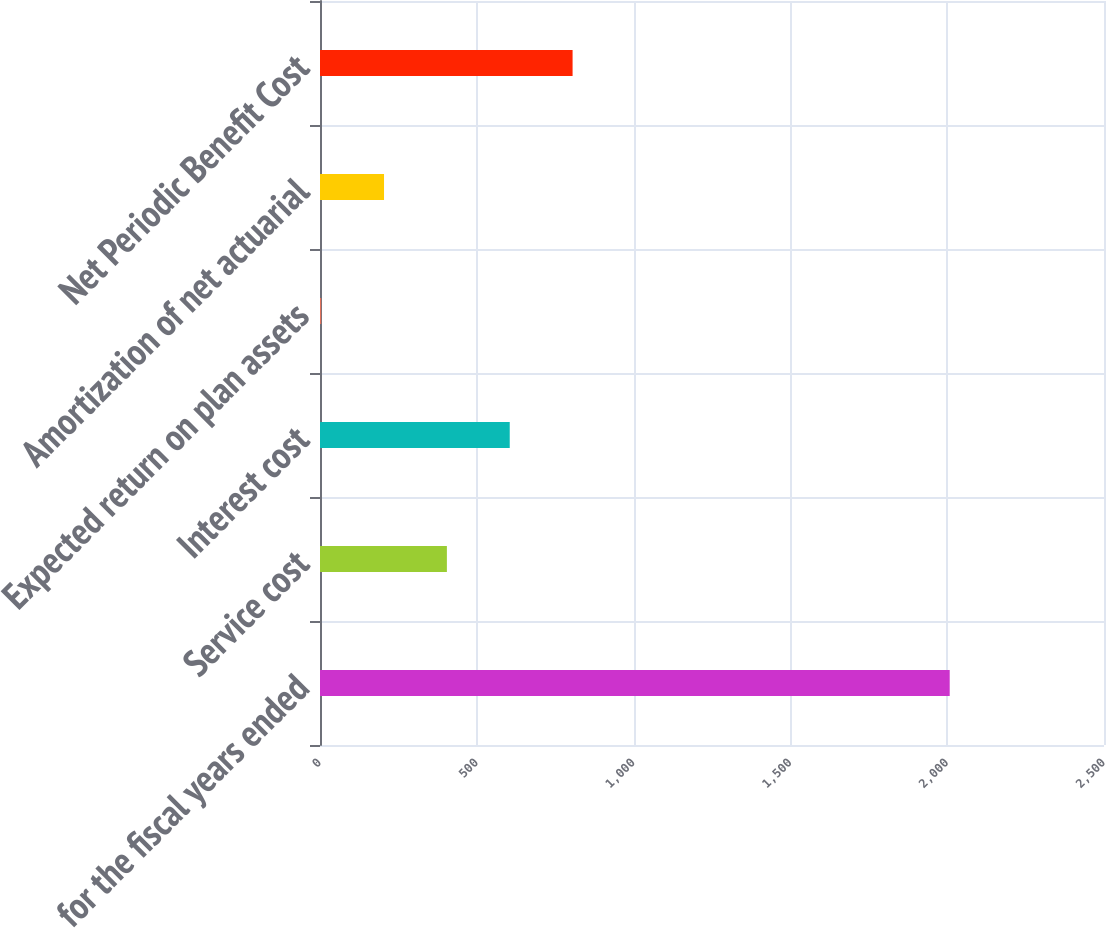Convert chart. <chart><loc_0><loc_0><loc_500><loc_500><bar_chart><fcel>for the fiscal years ended<fcel>Service cost<fcel>Interest cost<fcel>Expected return on plan assets<fcel>Amortization of net actuarial<fcel>Net Periodic Benefit Cost<nl><fcel>2008<fcel>404.61<fcel>605.03<fcel>3.77<fcel>204.19<fcel>805.45<nl></chart> 